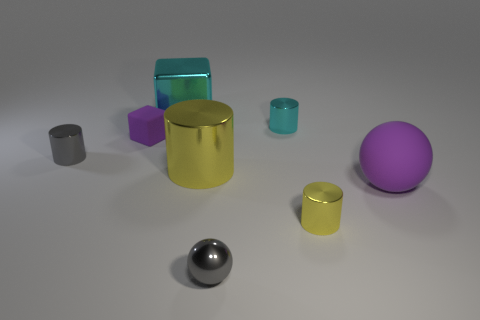How many objects are there in the image, and can you describe their colors? There are seven objects in the image. Starting from the left, there's a small grey cylinder, a blue transparent cube, a small violet cube, a large yellow cylinder, a small transparent teal cylinder, a purple matte sphere, and a metallic sphere in the foreground. 